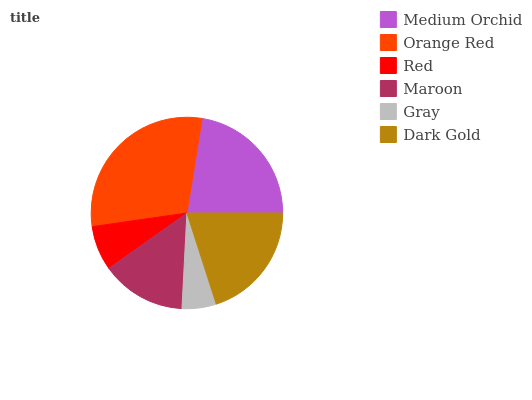Is Gray the minimum?
Answer yes or no. Yes. Is Orange Red the maximum?
Answer yes or no. Yes. Is Red the minimum?
Answer yes or no. No. Is Red the maximum?
Answer yes or no. No. Is Orange Red greater than Red?
Answer yes or no. Yes. Is Red less than Orange Red?
Answer yes or no. Yes. Is Red greater than Orange Red?
Answer yes or no. No. Is Orange Red less than Red?
Answer yes or no. No. Is Dark Gold the high median?
Answer yes or no. Yes. Is Maroon the low median?
Answer yes or no. Yes. Is Orange Red the high median?
Answer yes or no. No. Is Orange Red the low median?
Answer yes or no. No. 